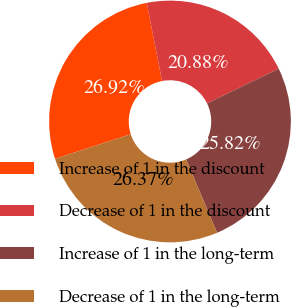Convert chart. <chart><loc_0><loc_0><loc_500><loc_500><pie_chart><fcel>Increase of 1 in the discount<fcel>Decrease of 1 in the discount<fcel>Increase of 1 in the long-term<fcel>Decrease of 1 in the long-term<nl><fcel>26.92%<fcel>20.88%<fcel>25.82%<fcel>26.37%<nl></chart> 